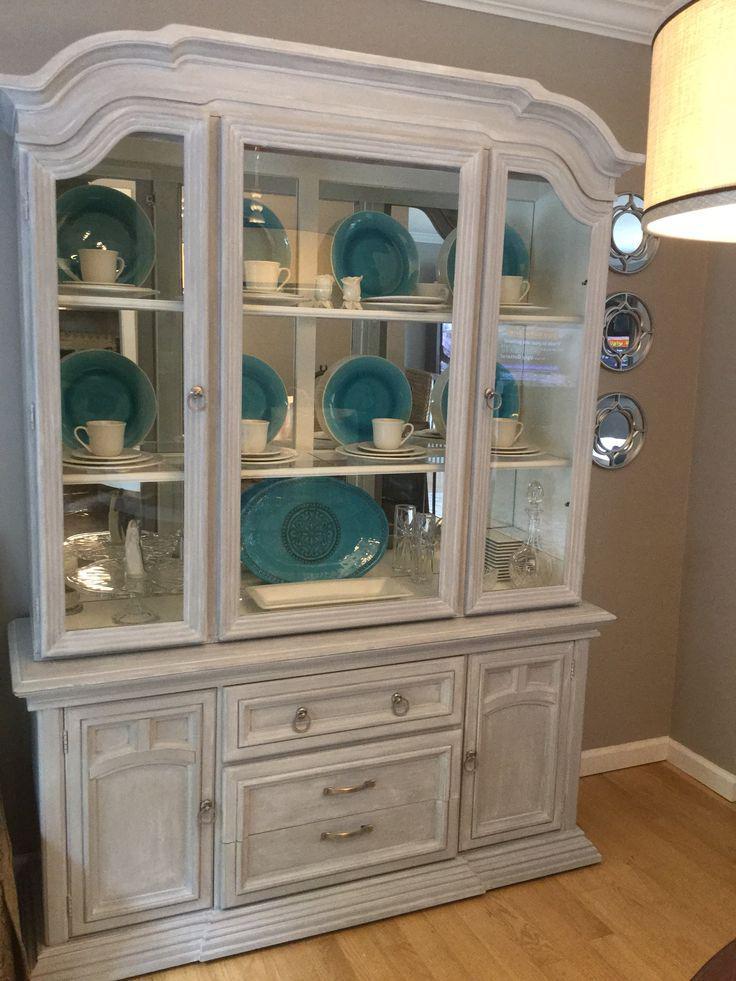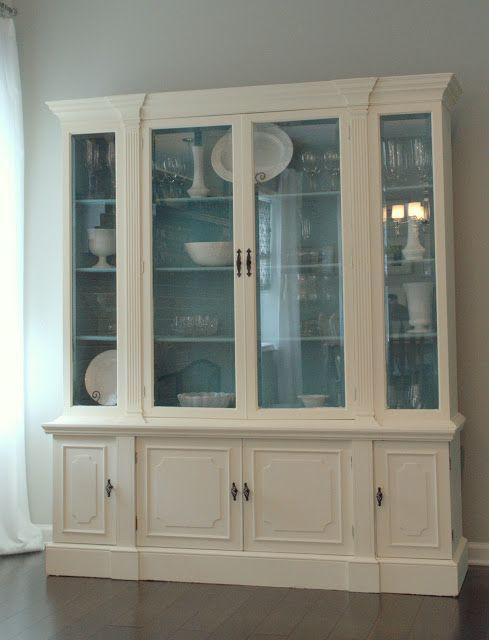The first image is the image on the left, the second image is the image on the right. Evaluate the accuracy of this statement regarding the images: "An image features a cabinet with an arched top and at least two glass doors.". Is it true? Answer yes or no. Yes. The first image is the image on the left, the second image is the image on the right. Assess this claim about the two images: "One flat topped wooden hutch has the same number of glass doors in its upper section as solid doors in its lower section and sits flush to the floor.". Correct or not? Answer yes or no. Yes. 